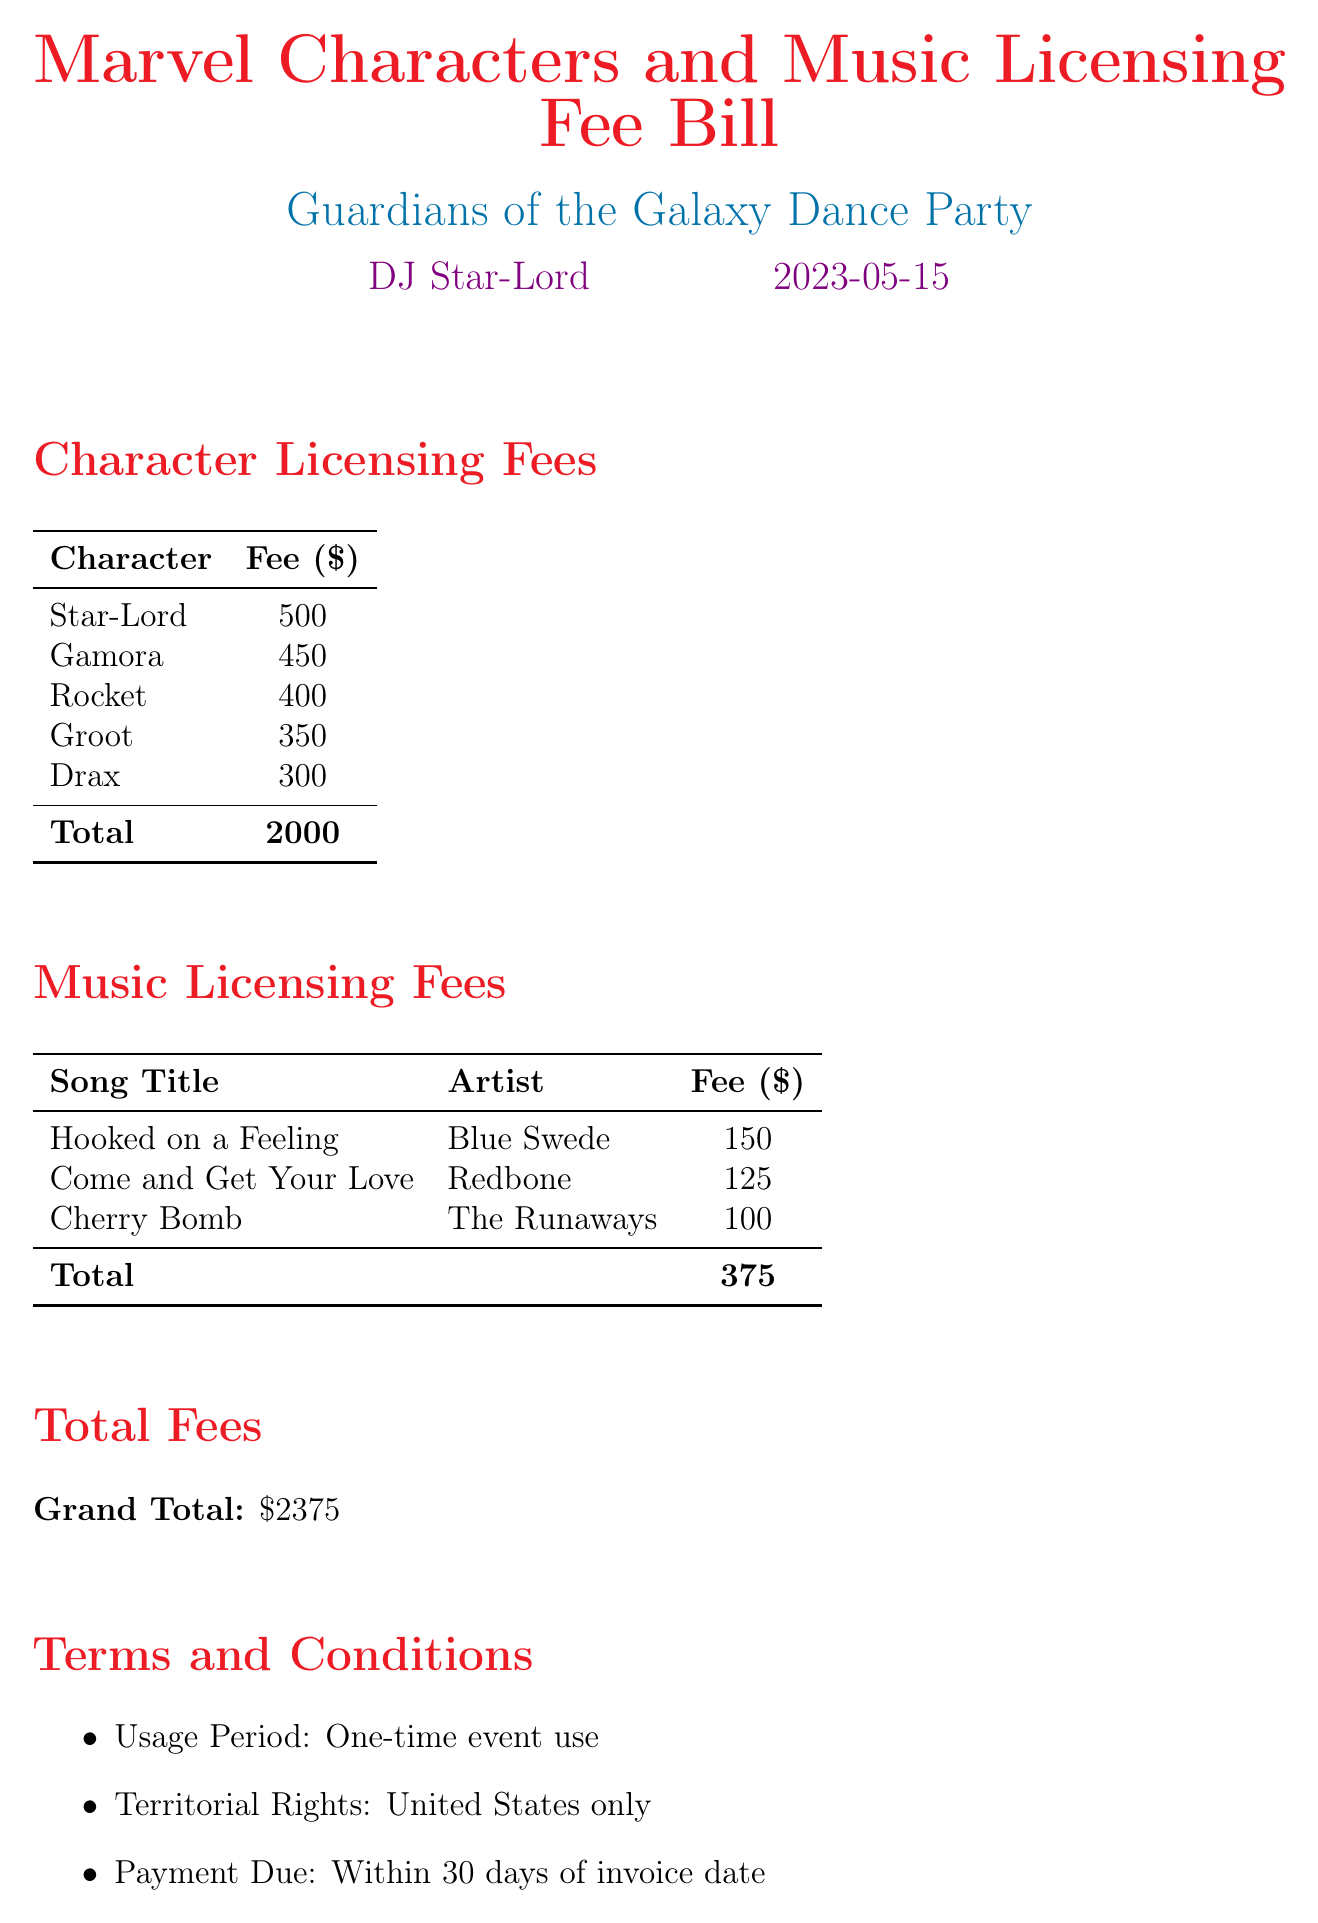what is the total licensing fee for characters? The total licensing fee for characters is found by adding the individual fees listed for each character, which total $2000.
Answer: $2000 who is the artist for "Hooked on a Feeling"? The document lists the artist for "Hooked on a Feeling" as Blue Swede.
Answer: Blue Swede what is the fee for Groot? The document specifies that the fee for Groot is $350.
Answer: $350 what is the grand total of fees? The grand total of fees is the total of character and music licensing fees, which sums up to $2375.
Answer: $2375 how many characters have a licensing fee greater than $400? By reviewing the fees, there are two characters (Star-Lord and Gamora) with fees greater than $400.
Answer: 2 what are the terms of payment? The payment terms state that payment is due within 30 days of invoice date, as mentioned in the terms and conditions section.
Answer: Within 30 days which song has the lowest licensing fee? The song with the lowest licensing fee listed is "Cherry Bomb" by The Runaways, with a fee of $100.
Answer: Cherry Bomb what is the usage period specified in the document? The usage period is specified as one-time event use in the terms and conditions section.
Answer: One-time event use which entity is listed as a licensor? The document states Marvel Entertainment, LLC & Universal Music Group as the licensors.
Answer: Marvel Entertainment, LLC & Universal Music Group 